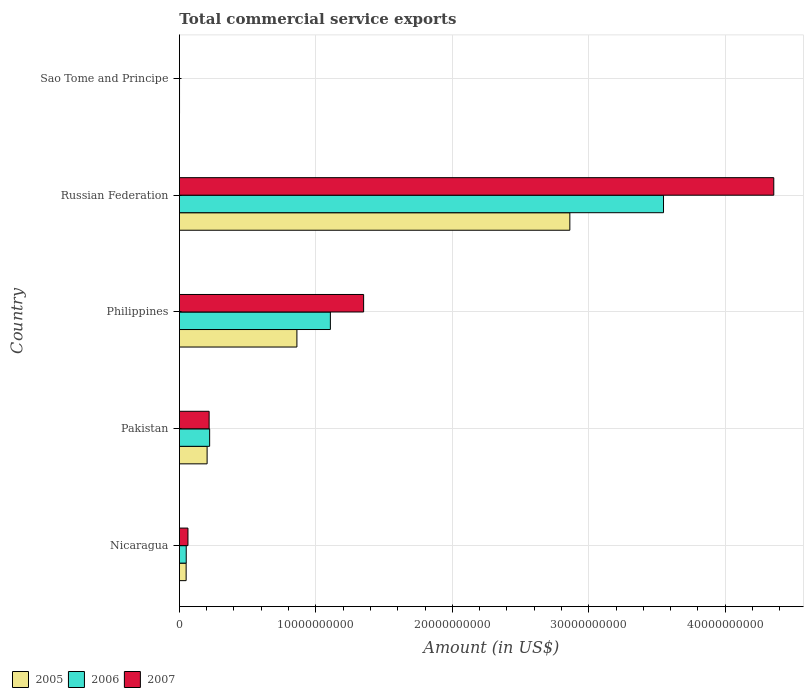How many different coloured bars are there?
Your answer should be very brief. 3. How many groups of bars are there?
Offer a terse response. 5. Are the number of bars per tick equal to the number of legend labels?
Your answer should be compact. Yes. What is the label of the 4th group of bars from the top?
Give a very brief answer. Pakistan. In how many cases, is the number of bars for a given country not equal to the number of legend labels?
Provide a short and direct response. 0. What is the total commercial service exports in 2007 in Philippines?
Your response must be concise. 1.35e+1. Across all countries, what is the maximum total commercial service exports in 2005?
Your answer should be very brief. 2.86e+1. Across all countries, what is the minimum total commercial service exports in 2005?
Offer a terse response. 8.86e+06. In which country was the total commercial service exports in 2006 maximum?
Ensure brevity in your answer.  Russian Federation. In which country was the total commercial service exports in 2006 minimum?
Provide a succinct answer. Sao Tome and Principe. What is the total total commercial service exports in 2006 in the graph?
Your answer should be very brief. 4.93e+1. What is the difference between the total commercial service exports in 2005 in Nicaragua and that in Philippines?
Your answer should be compact. -8.12e+09. What is the difference between the total commercial service exports in 2007 in Pakistan and the total commercial service exports in 2005 in Sao Tome and Principe?
Your response must be concise. 2.17e+09. What is the average total commercial service exports in 2006 per country?
Your answer should be very brief. 9.85e+09. What is the difference between the total commercial service exports in 2005 and total commercial service exports in 2007 in Sao Tome and Principe?
Offer a terse response. 2.43e+06. What is the ratio of the total commercial service exports in 2006 in Nicaragua to that in Russian Federation?
Ensure brevity in your answer.  0.01. What is the difference between the highest and the second highest total commercial service exports in 2007?
Your answer should be compact. 3.01e+1. What is the difference between the highest and the lowest total commercial service exports in 2006?
Your response must be concise. 3.55e+1. What does the 1st bar from the top in Sao Tome and Principe represents?
Your answer should be compact. 2007. What does the 1st bar from the bottom in Pakistan represents?
Your answer should be compact. 2005. Is it the case that in every country, the sum of the total commercial service exports in 2006 and total commercial service exports in 2005 is greater than the total commercial service exports in 2007?
Provide a short and direct response. Yes. Are the values on the major ticks of X-axis written in scientific E-notation?
Make the answer very short. No. Does the graph contain grids?
Offer a terse response. Yes. How many legend labels are there?
Your answer should be very brief. 3. How are the legend labels stacked?
Provide a short and direct response. Horizontal. What is the title of the graph?
Ensure brevity in your answer.  Total commercial service exports. What is the label or title of the X-axis?
Provide a succinct answer. Amount (in US$). What is the Amount (in US$) in 2005 in Nicaragua?
Make the answer very short. 4.93e+08. What is the Amount (in US$) in 2006 in Nicaragua?
Give a very brief answer. 5.00e+08. What is the Amount (in US$) of 2007 in Nicaragua?
Ensure brevity in your answer.  6.25e+08. What is the Amount (in US$) in 2005 in Pakistan?
Your answer should be very brief. 2.03e+09. What is the Amount (in US$) of 2006 in Pakistan?
Keep it short and to the point. 2.22e+09. What is the Amount (in US$) in 2007 in Pakistan?
Ensure brevity in your answer.  2.18e+09. What is the Amount (in US$) of 2005 in Philippines?
Your answer should be compact. 8.61e+09. What is the Amount (in US$) of 2006 in Philippines?
Provide a short and direct response. 1.11e+1. What is the Amount (in US$) of 2007 in Philippines?
Offer a very short reply. 1.35e+1. What is the Amount (in US$) in 2005 in Russian Federation?
Your response must be concise. 2.86e+1. What is the Amount (in US$) of 2006 in Russian Federation?
Offer a very short reply. 3.55e+1. What is the Amount (in US$) in 2007 in Russian Federation?
Your answer should be compact. 4.36e+1. What is the Amount (in US$) in 2005 in Sao Tome and Principe?
Your response must be concise. 8.86e+06. What is the Amount (in US$) in 2006 in Sao Tome and Principe?
Ensure brevity in your answer.  8.14e+06. What is the Amount (in US$) of 2007 in Sao Tome and Principe?
Offer a terse response. 6.43e+06. Across all countries, what is the maximum Amount (in US$) of 2005?
Ensure brevity in your answer.  2.86e+1. Across all countries, what is the maximum Amount (in US$) of 2006?
Keep it short and to the point. 3.55e+1. Across all countries, what is the maximum Amount (in US$) in 2007?
Make the answer very short. 4.36e+1. Across all countries, what is the minimum Amount (in US$) of 2005?
Your response must be concise. 8.86e+06. Across all countries, what is the minimum Amount (in US$) of 2006?
Make the answer very short. 8.14e+06. Across all countries, what is the minimum Amount (in US$) in 2007?
Offer a terse response. 6.43e+06. What is the total Amount (in US$) in 2005 in the graph?
Offer a very short reply. 3.98e+1. What is the total Amount (in US$) of 2006 in the graph?
Your answer should be compact. 4.93e+1. What is the total Amount (in US$) in 2007 in the graph?
Keep it short and to the point. 5.99e+1. What is the difference between the Amount (in US$) in 2005 in Nicaragua and that in Pakistan?
Give a very brief answer. -1.54e+09. What is the difference between the Amount (in US$) of 2006 in Nicaragua and that in Pakistan?
Offer a terse response. -1.72e+09. What is the difference between the Amount (in US$) in 2007 in Nicaragua and that in Pakistan?
Your answer should be very brief. -1.55e+09. What is the difference between the Amount (in US$) of 2005 in Nicaragua and that in Philippines?
Your response must be concise. -8.12e+09. What is the difference between the Amount (in US$) in 2006 in Nicaragua and that in Philippines?
Your answer should be very brief. -1.06e+1. What is the difference between the Amount (in US$) in 2007 in Nicaragua and that in Philippines?
Your answer should be very brief. -1.29e+1. What is the difference between the Amount (in US$) of 2005 in Nicaragua and that in Russian Federation?
Offer a very short reply. -2.81e+1. What is the difference between the Amount (in US$) of 2006 in Nicaragua and that in Russian Federation?
Provide a short and direct response. -3.50e+1. What is the difference between the Amount (in US$) of 2007 in Nicaragua and that in Russian Federation?
Make the answer very short. -4.29e+1. What is the difference between the Amount (in US$) in 2005 in Nicaragua and that in Sao Tome and Principe?
Your answer should be very brief. 4.85e+08. What is the difference between the Amount (in US$) of 2006 in Nicaragua and that in Sao Tome and Principe?
Your answer should be compact. 4.91e+08. What is the difference between the Amount (in US$) of 2007 in Nicaragua and that in Sao Tome and Principe?
Your answer should be very brief. 6.19e+08. What is the difference between the Amount (in US$) of 2005 in Pakistan and that in Philippines?
Make the answer very short. -6.58e+09. What is the difference between the Amount (in US$) of 2006 in Pakistan and that in Philippines?
Offer a terse response. -8.85e+09. What is the difference between the Amount (in US$) of 2007 in Pakistan and that in Philippines?
Offer a terse response. -1.13e+1. What is the difference between the Amount (in US$) in 2005 in Pakistan and that in Russian Federation?
Provide a succinct answer. -2.66e+1. What is the difference between the Amount (in US$) in 2006 in Pakistan and that in Russian Federation?
Offer a very short reply. -3.33e+1. What is the difference between the Amount (in US$) in 2007 in Pakistan and that in Russian Federation?
Your answer should be compact. -4.14e+1. What is the difference between the Amount (in US$) in 2005 in Pakistan and that in Sao Tome and Principe?
Your answer should be very brief. 2.02e+09. What is the difference between the Amount (in US$) in 2006 in Pakistan and that in Sao Tome and Principe?
Offer a very short reply. 2.21e+09. What is the difference between the Amount (in US$) in 2007 in Pakistan and that in Sao Tome and Principe?
Keep it short and to the point. 2.17e+09. What is the difference between the Amount (in US$) of 2005 in Philippines and that in Russian Federation?
Keep it short and to the point. -2.00e+1. What is the difference between the Amount (in US$) in 2006 in Philippines and that in Russian Federation?
Your answer should be compact. -2.44e+1. What is the difference between the Amount (in US$) of 2007 in Philippines and that in Russian Federation?
Offer a very short reply. -3.01e+1. What is the difference between the Amount (in US$) in 2005 in Philippines and that in Sao Tome and Principe?
Ensure brevity in your answer.  8.60e+09. What is the difference between the Amount (in US$) of 2006 in Philippines and that in Sao Tome and Principe?
Offer a very short reply. 1.11e+1. What is the difference between the Amount (in US$) in 2007 in Philippines and that in Sao Tome and Principe?
Ensure brevity in your answer.  1.35e+1. What is the difference between the Amount (in US$) in 2005 in Russian Federation and that in Sao Tome and Principe?
Provide a succinct answer. 2.86e+1. What is the difference between the Amount (in US$) in 2006 in Russian Federation and that in Sao Tome and Principe?
Ensure brevity in your answer.  3.55e+1. What is the difference between the Amount (in US$) of 2007 in Russian Federation and that in Sao Tome and Principe?
Provide a succinct answer. 4.36e+1. What is the difference between the Amount (in US$) of 2005 in Nicaragua and the Amount (in US$) of 2006 in Pakistan?
Make the answer very short. -1.72e+09. What is the difference between the Amount (in US$) of 2005 in Nicaragua and the Amount (in US$) of 2007 in Pakistan?
Make the answer very short. -1.68e+09. What is the difference between the Amount (in US$) of 2006 in Nicaragua and the Amount (in US$) of 2007 in Pakistan?
Offer a very short reply. -1.68e+09. What is the difference between the Amount (in US$) in 2005 in Nicaragua and the Amount (in US$) in 2006 in Philippines?
Your response must be concise. -1.06e+1. What is the difference between the Amount (in US$) of 2005 in Nicaragua and the Amount (in US$) of 2007 in Philippines?
Keep it short and to the point. -1.30e+1. What is the difference between the Amount (in US$) of 2006 in Nicaragua and the Amount (in US$) of 2007 in Philippines?
Ensure brevity in your answer.  -1.30e+1. What is the difference between the Amount (in US$) of 2005 in Nicaragua and the Amount (in US$) of 2006 in Russian Federation?
Your answer should be very brief. -3.50e+1. What is the difference between the Amount (in US$) of 2005 in Nicaragua and the Amount (in US$) of 2007 in Russian Federation?
Give a very brief answer. -4.31e+1. What is the difference between the Amount (in US$) in 2006 in Nicaragua and the Amount (in US$) in 2007 in Russian Federation?
Keep it short and to the point. -4.31e+1. What is the difference between the Amount (in US$) in 2005 in Nicaragua and the Amount (in US$) in 2006 in Sao Tome and Principe?
Your answer should be very brief. 4.85e+08. What is the difference between the Amount (in US$) of 2005 in Nicaragua and the Amount (in US$) of 2007 in Sao Tome and Principe?
Provide a short and direct response. 4.87e+08. What is the difference between the Amount (in US$) of 2006 in Nicaragua and the Amount (in US$) of 2007 in Sao Tome and Principe?
Ensure brevity in your answer.  4.93e+08. What is the difference between the Amount (in US$) of 2005 in Pakistan and the Amount (in US$) of 2006 in Philippines?
Make the answer very short. -9.03e+09. What is the difference between the Amount (in US$) of 2005 in Pakistan and the Amount (in US$) of 2007 in Philippines?
Keep it short and to the point. -1.15e+1. What is the difference between the Amount (in US$) in 2006 in Pakistan and the Amount (in US$) in 2007 in Philippines?
Your answer should be very brief. -1.13e+1. What is the difference between the Amount (in US$) in 2005 in Pakistan and the Amount (in US$) in 2006 in Russian Federation?
Offer a very short reply. -3.35e+1. What is the difference between the Amount (in US$) in 2005 in Pakistan and the Amount (in US$) in 2007 in Russian Federation?
Make the answer very short. -4.15e+1. What is the difference between the Amount (in US$) of 2006 in Pakistan and the Amount (in US$) of 2007 in Russian Federation?
Provide a short and direct response. -4.13e+1. What is the difference between the Amount (in US$) of 2005 in Pakistan and the Amount (in US$) of 2006 in Sao Tome and Principe?
Provide a short and direct response. 2.02e+09. What is the difference between the Amount (in US$) in 2005 in Pakistan and the Amount (in US$) in 2007 in Sao Tome and Principe?
Provide a succinct answer. 2.02e+09. What is the difference between the Amount (in US$) of 2006 in Pakistan and the Amount (in US$) of 2007 in Sao Tome and Principe?
Your answer should be very brief. 2.21e+09. What is the difference between the Amount (in US$) in 2005 in Philippines and the Amount (in US$) in 2006 in Russian Federation?
Your response must be concise. -2.69e+1. What is the difference between the Amount (in US$) in 2005 in Philippines and the Amount (in US$) in 2007 in Russian Federation?
Provide a succinct answer. -3.50e+1. What is the difference between the Amount (in US$) of 2006 in Philippines and the Amount (in US$) of 2007 in Russian Federation?
Your response must be concise. -3.25e+1. What is the difference between the Amount (in US$) in 2005 in Philippines and the Amount (in US$) in 2006 in Sao Tome and Principe?
Keep it short and to the point. 8.60e+09. What is the difference between the Amount (in US$) of 2005 in Philippines and the Amount (in US$) of 2007 in Sao Tome and Principe?
Your answer should be compact. 8.60e+09. What is the difference between the Amount (in US$) of 2006 in Philippines and the Amount (in US$) of 2007 in Sao Tome and Principe?
Make the answer very short. 1.11e+1. What is the difference between the Amount (in US$) of 2005 in Russian Federation and the Amount (in US$) of 2006 in Sao Tome and Principe?
Give a very brief answer. 2.86e+1. What is the difference between the Amount (in US$) in 2005 in Russian Federation and the Amount (in US$) in 2007 in Sao Tome and Principe?
Provide a short and direct response. 2.86e+1. What is the difference between the Amount (in US$) in 2006 in Russian Federation and the Amount (in US$) in 2007 in Sao Tome and Principe?
Provide a short and direct response. 3.55e+1. What is the average Amount (in US$) in 2005 per country?
Offer a terse response. 7.95e+09. What is the average Amount (in US$) of 2006 per country?
Offer a very short reply. 9.85e+09. What is the average Amount (in US$) in 2007 per country?
Ensure brevity in your answer.  1.20e+1. What is the difference between the Amount (in US$) in 2005 and Amount (in US$) in 2006 in Nicaragua?
Your answer should be compact. -6.20e+06. What is the difference between the Amount (in US$) in 2005 and Amount (in US$) in 2007 in Nicaragua?
Your answer should be very brief. -1.32e+08. What is the difference between the Amount (in US$) of 2006 and Amount (in US$) of 2007 in Nicaragua?
Your answer should be very brief. -1.26e+08. What is the difference between the Amount (in US$) of 2005 and Amount (in US$) of 2006 in Pakistan?
Your response must be concise. -1.85e+08. What is the difference between the Amount (in US$) in 2005 and Amount (in US$) in 2007 in Pakistan?
Provide a short and direct response. -1.48e+08. What is the difference between the Amount (in US$) of 2006 and Amount (in US$) of 2007 in Pakistan?
Your answer should be very brief. 3.73e+07. What is the difference between the Amount (in US$) of 2005 and Amount (in US$) of 2006 in Philippines?
Your answer should be very brief. -2.45e+09. What is the difference between the Amount (in US$) in 2005 and Amount (in US$) in 2007 in Philippines?
Ensure brevity in your answer.  -4.89e+09. What is the difference between the Amount (in US$) of 2006 and Amount (in US$) of 2007 in Philippines?
Your answer should be very brief. -2.44e+09. What is the difference between the Amount (in US$) in 2005 and Amount (in US$) in 2006 in Russian Federation?
Keep it short and to the point. -6.87e+09. What is the difference between the Amount (in US$) in 2005 and Amount (in US$) in 2007 in Russian Federation?
Provide a succinct answer. -1.49e+1. What is the difference between the Amount (in US$) of 2006 and Amount (in US$) of 2007 in Russian Federation?
Ensure brevity in your answer.  -8.08e+09. What is the difference between the Amount (in US$) in 2005 and Amount (in US$) in 2006 in Sao Tome and Principe?
Offer a terse response. 7.25e+05. What is the difference between the Amount (in US$) of 2005 and Amount (in US$) of 2007 in Sao Tome and Principe?
Provide a succinct answer. 2.43e+06. What is the difference between the Amount (in US$) in 2006 and Amount (in US$) in 2007 in Sao Tome and Principe?
Provide a short and direct response. 1.71e+06. What is the ratio of the Amount (in US$) in 2005 in Nicaragua to that in Pakistan?
Keep it short and to the point. 0.24. What is the ratio of the Amount (in US$) of 2006 in Nicaragua to that in Pakistan?
Make the answer very short. 0.23. What is the ratio of the Amount (in US$) in 2007 in Nicaragua to that in Pakistan?
Your answer should be very brief. 0.29. What is the ratio of the Amount (in US$) of 2005 in Nicaragua to that in Philippines?
Your answer should be compact. 0.06. What is the ratio of the Amount (in US$) in 2006 in Nicaragua to that in Philippines?
Provide a succinct answer. 0.05. What is the ratio of the Amount (in US$) of 2007 in Nicaragua to that in Philippines?
Your response must be concise. 0.05. What is the ratio of the Amount (in US$) in 2005 in Nicaragua to that in Russian Federation?
Give a very brief answer. 0.02. What is the ratio of the Amount (in US$) of 2006 in Nicaragua to that in Russian Federation?
Offer a terse response. 0.01. What is the ratio of the Amount (in US$) in 2007 in Nicaragua to that in Russian Federation?
Provide a short and direct response. 0.01. What is the ratio of the Amount (in US$) in 2005 in Nicaragua to that in Sao Tome and Principe?
Keep it short and to the point. 55.69. What is the ratio of the Amount (in US$) of 2006 in Nicaragua to that in Sao Tome and Principe?
Keep it short and to the point. 61.41. What is the ratio of the Amount (in US$) in 2007 in Nicaragua to that in Sao Tome and Principe?
Provide a succinct answer. 97.29. What is the ratio of the Amount (in US$) in 2005 in Pakistan to that in Philippines?
Ensure brevity in your answer.  0.24. What is the ratio of the Amount (in US$) in 2006 in Pakistan to that in Philippines?
Offer a very short reply. 0.2. What is the ratio of the Amount (in US$) of 2007 in Pakistan to that in Philippines?
Offer a very short reply. 0.16. What is the ratio of the Amount (in US$) of 2005 in Pakistan to that in Russian Federation?
Your response must be concise. 0.07. What is the ratio of the Amount (in US$) of 2006 in Pakistan to that in Russian Federation?
Your response must be concise. 0.06. What is the ratio of the Amount (in US$) in 2007 in Pakistan to that in Russian Federation?
Provide a short and direct response. 0.05. What is the ratio of the Amount (in US$) of 2005 in Pakistan to that in Sao Tome and Principe?
Make the answer very short. 229.11. What is the ratio of the Amount (in US$) in 2006 in Pakistan to that in Sao Tome and Principe?
Give a very brief answer. 272.28. What is the ratio of the Amount (in US$) in 2007 in Pakistan to that in Sao Tome and Principe?
Provide a succinct answer. 338.77. What is the ratio of the Amount (in US$) in 2005 in Philippines to that in Russian Federation?
Your response must be concise. 0.3. What is the ratio of the Amount (in US$) of 2006 in Philippines to that in Russian Federation?
Provide a succinct answer. 0.31. What is the ratio of the Amount (in US$) in 2007 in Philippines to that in Russian Federation?
Ensure brevity in your answer.  0.31. What is the ratio of the Amount (in US$) in 2005 in Philippines to that in Sao Tome and Principe?
Make the answer very short. 971.83. What is the ratio of the Amount (in US$) of 2006 in Philippines to that in Sao Tome and Principe?
Make the answer very short. 1360.07. What is the ratio of the Amount (in US$) of 2007 in Philippines to that in Sao Tome and Principe?
Provide a short and direct response. 2100.4. What is the ratio of the Amount (in US$) in 2005 in Russian Federation to that in Sao Tome and Principe?
Offer a terse response. 3229.6. What is the ratio of the Amount (in US$) in 2006 in Russian Federation to that in Sao Tome and Principe?
Ensure brevity in your answer.  4361.62. What is the ratio of the Amount (in US$) in 2007 in Russian Federation to that in Sao Tome and Principe?
Give a very brief answer. 6776.89. What is the difference between the highest and the second highest Amount (in US$) of 2005?
Keep it short and to the point. 2.00e+1. What is the difference between the highest and the second highest Amount (in US$) of 2006?
Your answer should be very brief. 2.44e+1. What is the difference between the highest and the second highest Amount (in US$) in 2007?
Your answer should be very brief. 3.01e+1. What is the difference between the highest and the lowest Amount (in US$) of 2005?
Ensure brevity in your answer.  2.86e+1. What is the difference between the highest and the lowest Amount (in US$) of 2006?
Provide a short and direct response. 3.55e+1. What is the difference between the highest and the lowest Amount (in US$) in 2007?
Your answer should be very brief. 4.36e+1. 